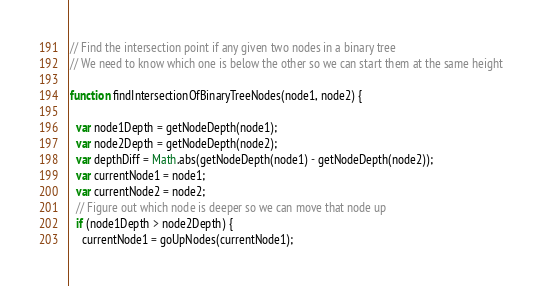Convert code to text. <code><loc_0><loc_0><loc_500><loc_500><_JavaScript_>// Find the intersection point if any given two nodes in a binary tree
// We need to know which one is below the other so we can start them at the same height

function findIntersectionOfBinaryTreeNodes(node1, node2) {
  
  var node1Depth = getNodeDepth(node1);
  var node2Depth = getNodeDepth(node2);
  var depthDiff = Math.abs(getNodeDepth(node1) - getNodeDepth(node2));
  var currentNode1 = node1;
  var currentNode2 = node2;
  // Figure out which node is deeper so we can move that node up
  if (node1Depth > node2Depth) {
    currentNode1 = goUpNodes(currentNode1);</code> 